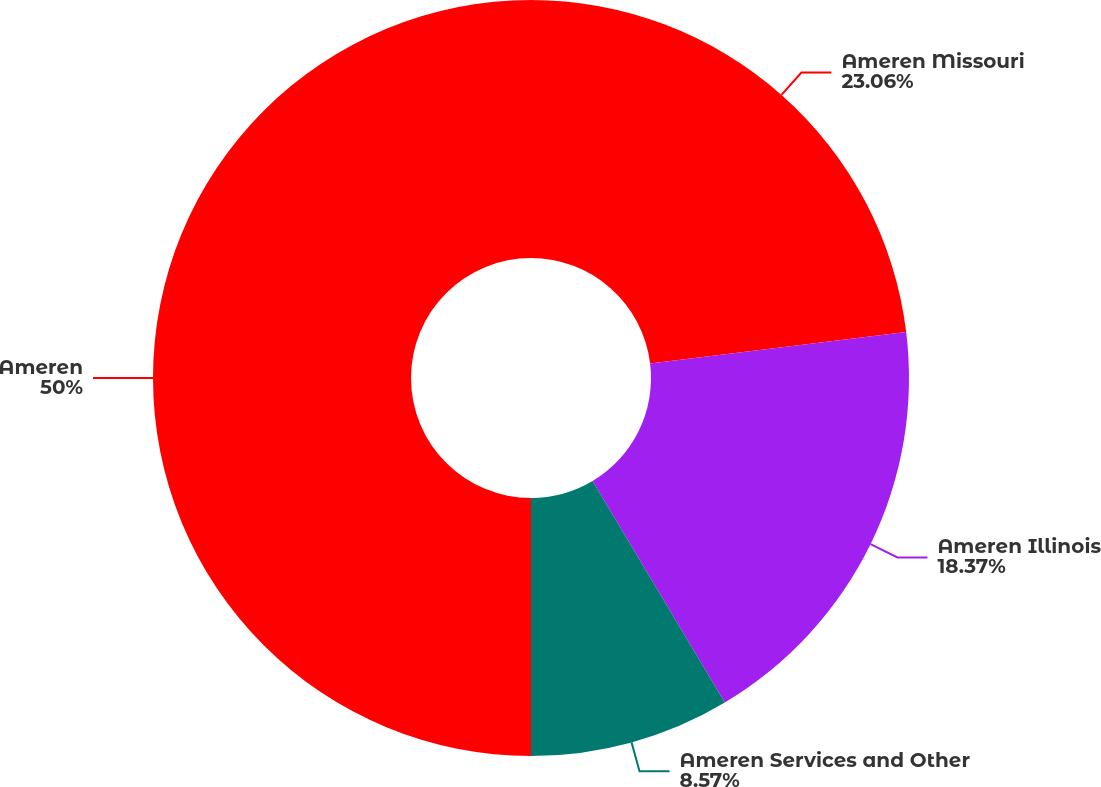Convert chart to OTSL. <chart><loc_0><loc_0><loc_500><loc_500><pie_chart><fcel>Ameren Missouri<fcel>Ameren Illinois<fcel>Ameren Services and Other<fcel>Ameren<nl><fcel>23.06%<fcel>18.37%<fcel>8.57%<fcel>50.0%<nl></chart> 